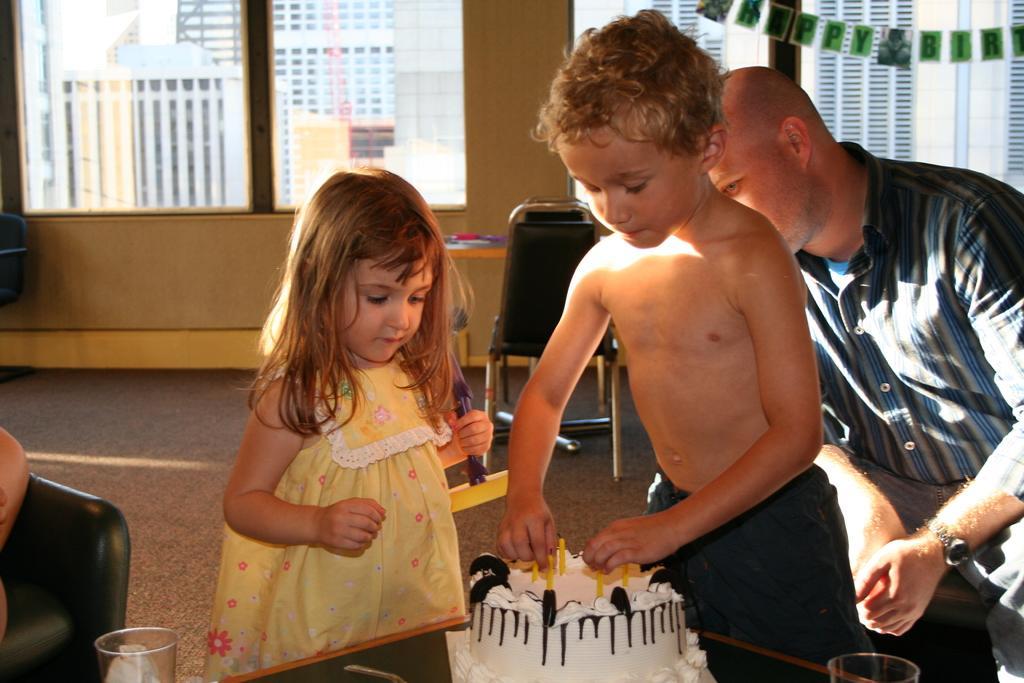Can you describe this image briefly? In this picture there is a small boy shirtless standing at the white cake and arranging the candles. Beside there is a girl wearing a yellow color dress and looking to the cake. Behind there is a father wearing a blue color shirt is sitting on the chair and watching them. In the background we can see the glass window and a brown color wall. 